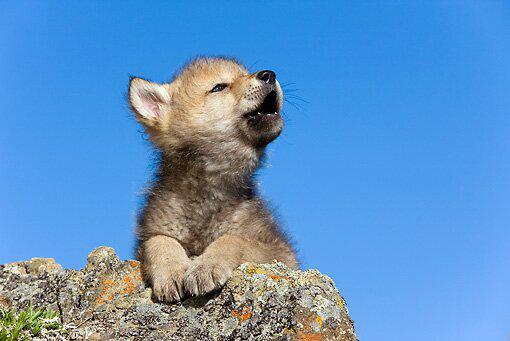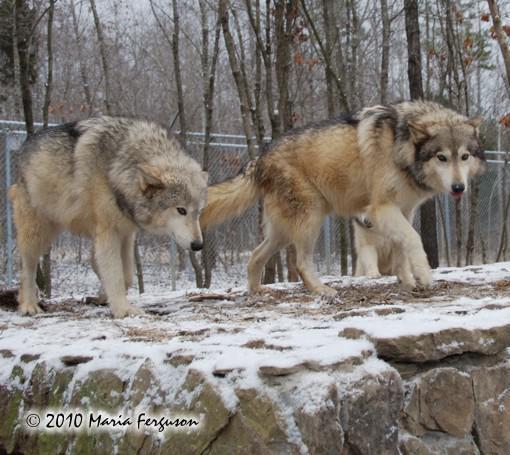The first image is the image on the left, the second image is the image on the right. Evaluate the accuracy of this statement regarding the images: "The combined images contain four wolves, including two adult wolves sitting upright with heads lifted, eyes shut, and mouths open in a howling pose.". Is it true? Answer yes or no. No. The first image is the image on the left, the second image is the image on the right. For the images displayed, is the sentence "There are two wolves in each image." factually correct? Answer yes or no. No. 